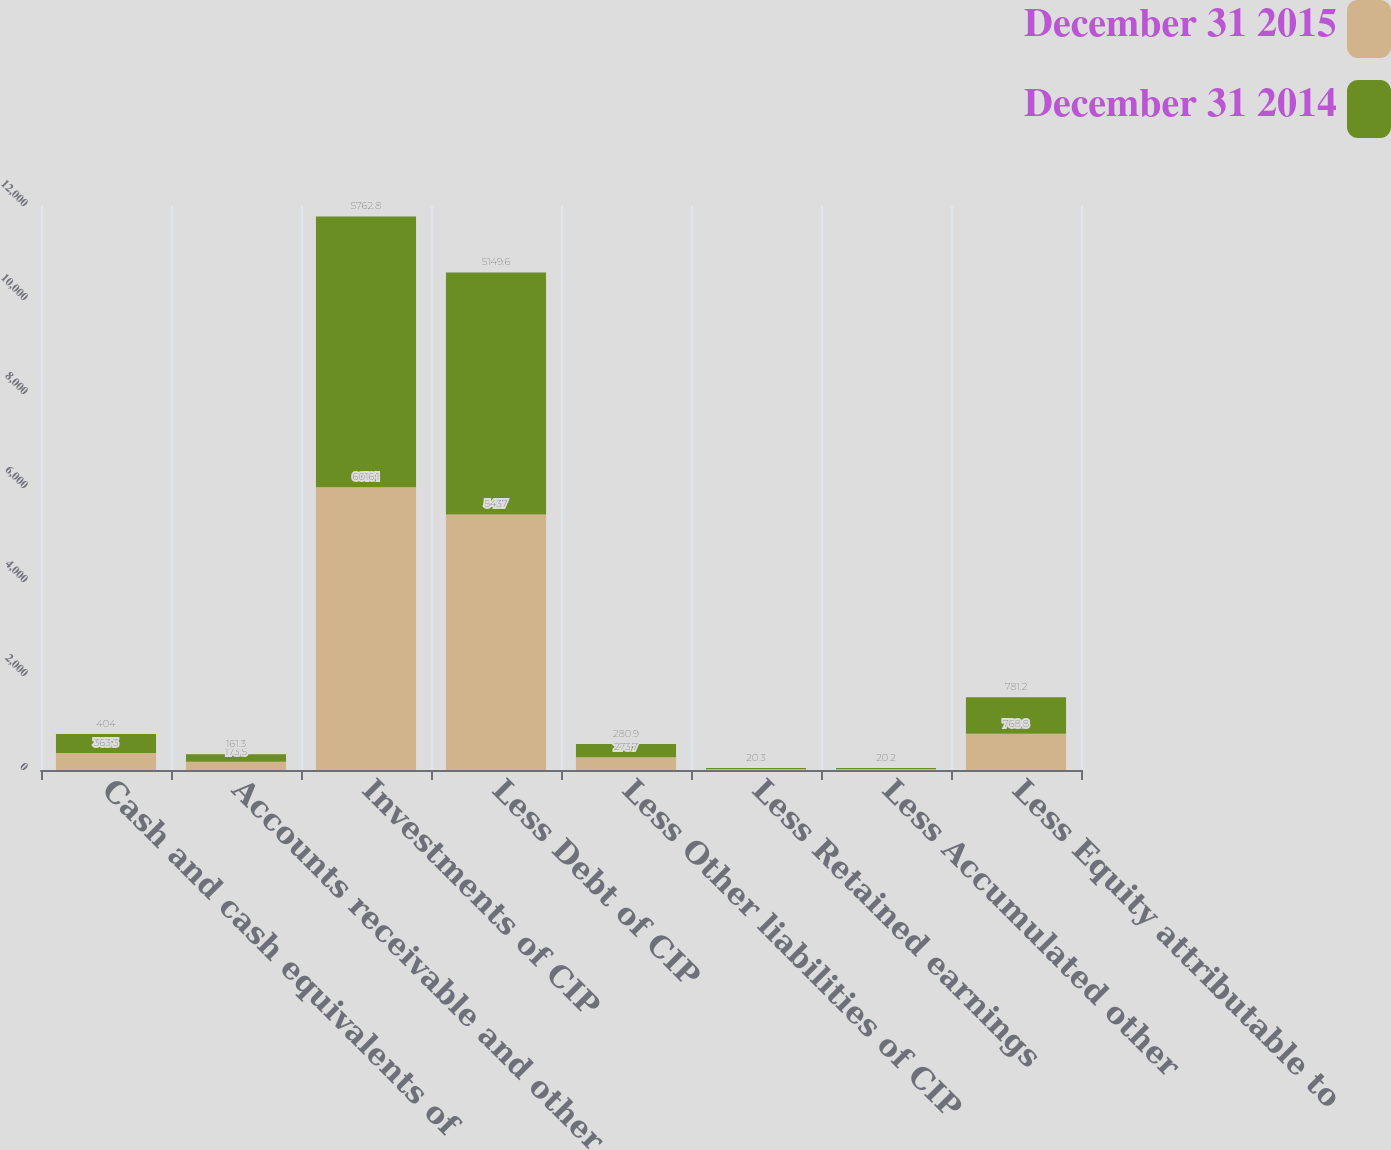<chart> <loc_0><loc_0><loc_500><loc_500><stacked_bar_chart><ecel><fcel>Cash and cash equivalents of<fcel>Accounts receivable and other<fcel>Investments of CIP<fcel>Less Debt of CIP<fcel>Less Other liabilities of CIP<fcel>Less Retained earnings<fcel>Less Accumulated other<fcel>Less Equity attributable to<nl><fcel>December 31 2015<fcel>363.3<fcel>173.5<fcel>6016.1<fcel>5437<fcel>273.7<fcel>20.1<fcel>20.1<fcel>768.8<nl><fcel>December 31 2014<fcel>404<fcel>161.3<fcel>5762.8<fcel>5149.6<fcel>280.9<fcel>20.3<fcel>20.2<fcel>781.2<nl></chart> 